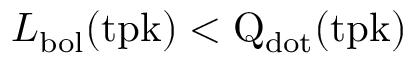Convert formula to latex. <formula><loc_0><loc_0><loc_500><loc_500>L _ { b o l } ( t p k ) < Q _ { \mathrm { d o t } } ( \mathrm { t p k ) }</formula> 